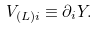Convert formula to latex. <formula><loc_0><loc_0><loc_500><loc_500>V _ { ( L ) i } \equiv \partial _ { i } Y .</formula> 